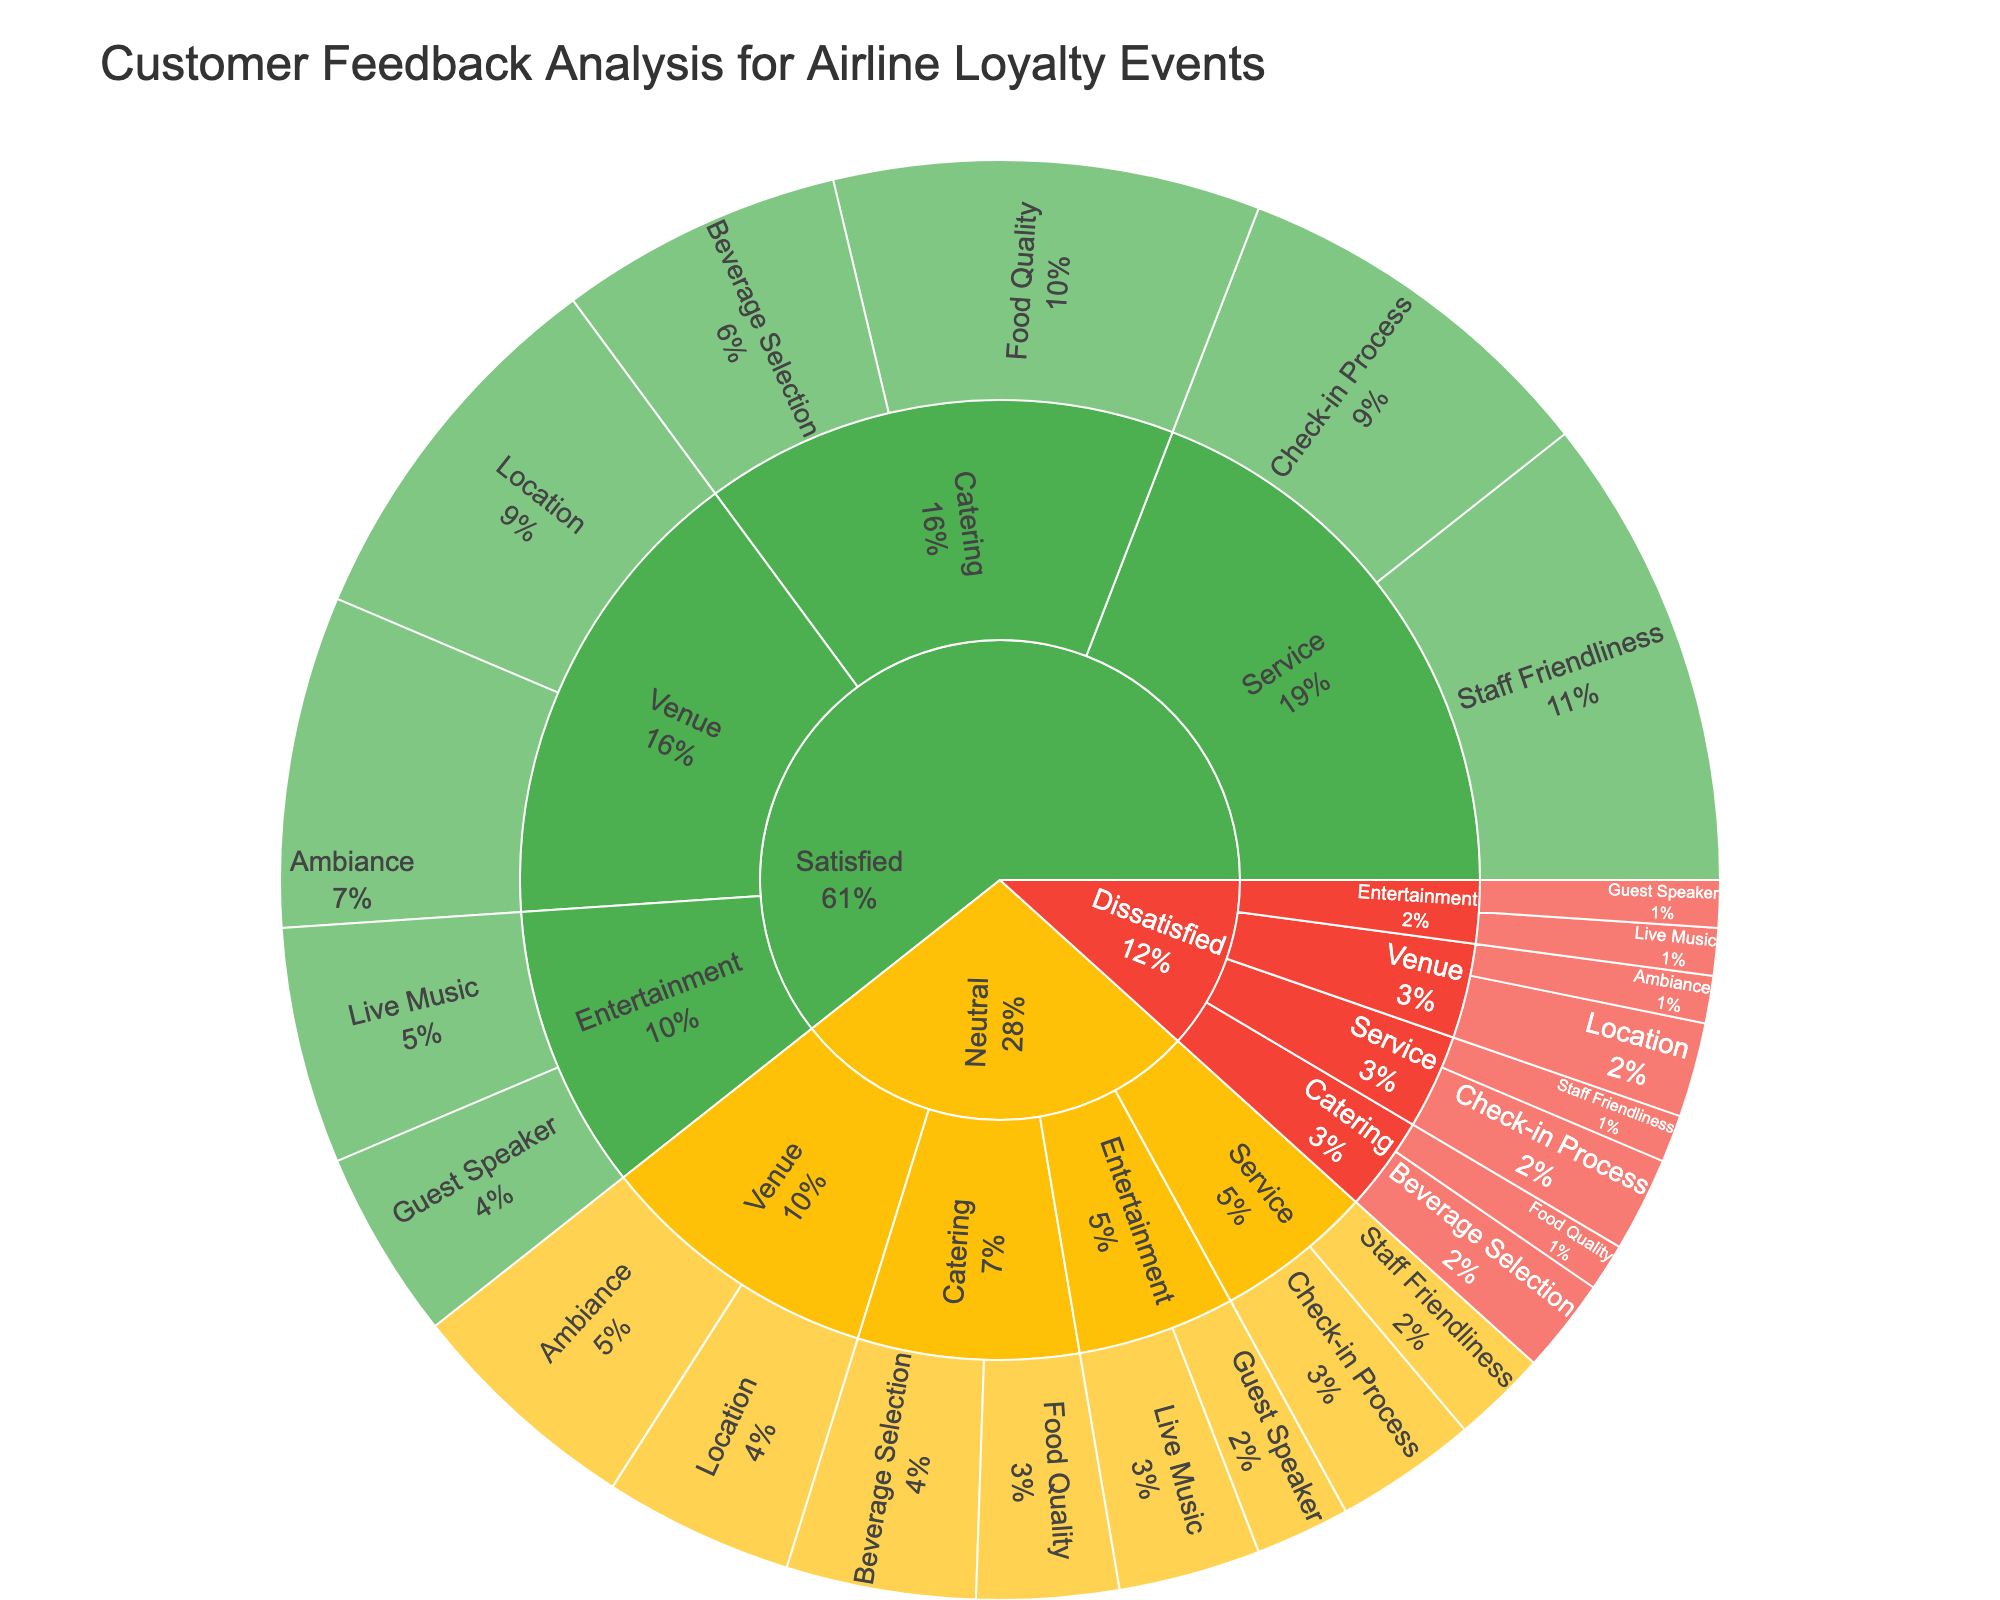What is the primary color used to represent 'Satisfied' feedback? The sunburst plot uses a distinct color scheme to represent each satisfaction level. By looking at the segments that are labeled 'Satisfied', we can identify the primary color used.
Answer: Green Which 'Aspect' under 'Service' had the highest 'Satisfied' rating? To determine this, navigate to the categories under 'Service' and then identify which 'Aspect' under 'Satisfied' has the largest numerical value. The aspect with the largest segment in the 'Satisfied' section of 'Service' has the highest rating.
Answer: Staff Friendliness How many points in total contribute to 'Neutral' feedback from the 'Venue' category? By adding up the values under 'Neutral' feedback for the 'Location' and 'Ambiance' subcategories within 'Venue', we can find the total points. The values are 20 (Location) + 25 (Ambiance).
Answer: 45 Is the 'Food Quality' feedback higher for 'Satisfied' or 'Neutral' customers? To answer this, compare the values of 'Food Quality' under 'Satisfied' and 'Neutral' feedback sections. Look for the 'Food Quality' aspect under 'Catering' in both categories.
Answer: Satisfied What's the sum of 'Satisfied' feedback points across all 'Subcategories'? Sum the values of all subcategories under the 'Satisfied' category: Venue (40 + 35) + Catering (45 + 30) + Entertainment (25 + 20) + Service (50 + 40).
Answer: 285 Which 'Aspect' in the 'Dissatisfied' category under 'Service' has double the value of another aspect within the same category? Navigate the 'Dissatisfied' segment and focus on 'Service'. Compare the numerical values for 'Staff Friendliness' and 'Check-in Process'. 'Check-in Process' (10) is double that of 'Staff Friendliness' (5).
Answer: Check-in Process What proportion of ‘Satisfied’ feedback comes from the 'Catering' category? Calculate the total 'Satisfied' value and then find the proportion from 'Catering'. Satisfied total: 285. Catering: (45 + 30). The proportion is (75 / 285).
Answer: 26.3% Which satisfaction level has the least variety in feedback categories? Examine the sections for Satisfied, Neutral, and Dissatisfied. Count the different subcategories under each segment. 'Dissatisfied' has Venue, Catering, Entertainment, and Service, identical to other categories. Thus, none differ in variety.
Answer: Equal variety 